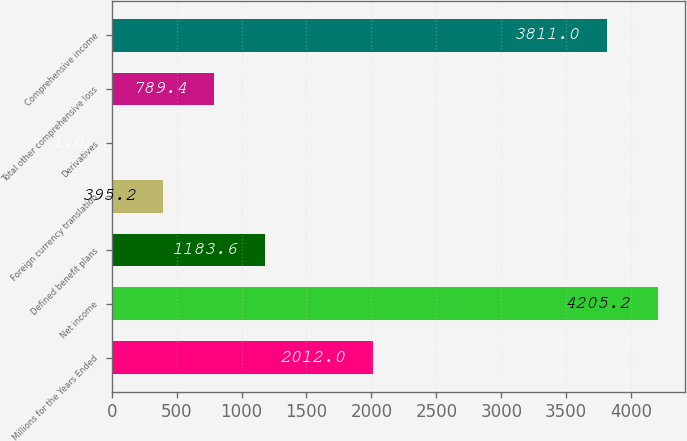Convert chart. <chart><loc_0><loc_0><loc_500><loc_500><bar_chart><fcel>Millions for the Years Ended<fcel>Net income<fcel>Defined benefit plans<fcel>Foreign currency translation<fcel>Derivatives<fcel>Total other comprehensive loss<fcel>Comprehensive income<nl><fcel>2012<fcel>4205.2<fcel>1183.6<fcel>395.2<fcel>1<fcel>789.4<fcel>3811<nl></chart> 